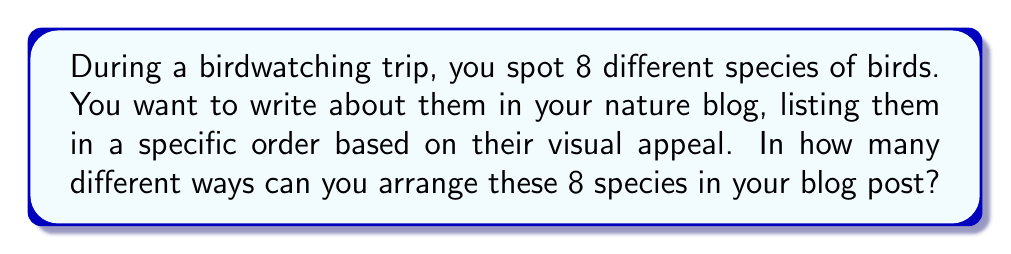Teach me how to tackle this problem. To solve this problem, we need to use the concept of permutations. A permutation is an arrangement of objects where order matters. In this case, we are arranging 8 different bird species, and the order in which we list them is important.

The formula for permutations of n distinct objects is:

$$P(n) = n!$$

Where $n!$ (n factorial) is the product of all positive integers less than or equal to n.

In our case, $n = 8$ (the number of bird species), so we calculate:

$$P(8) = 8!$$

Let's expand this:

$$\begin{align*}
8! &= 8 \times 7 \times 6 \times 5 \times 4 \times 3 \times 2 \times 1 \\
&= 40,320
\end{align*}$$

This means there are 40,320 different ways to arrange the 8 bird species in the blog post.

To understand this intuitively:
1. For the first position, we have 8 choices.
2. For the second position, we have 7 remaining choices.
3. For the third position, we have 6 remaining choices.
4. And so on, until we have only 1 choice for the last position.

Multiplying these choices together gives us $8 \times 7 \times 6 \times 5 \times 4 \times 3 \times 2 \times 1 = 40,320$.
Answer: 40,320 